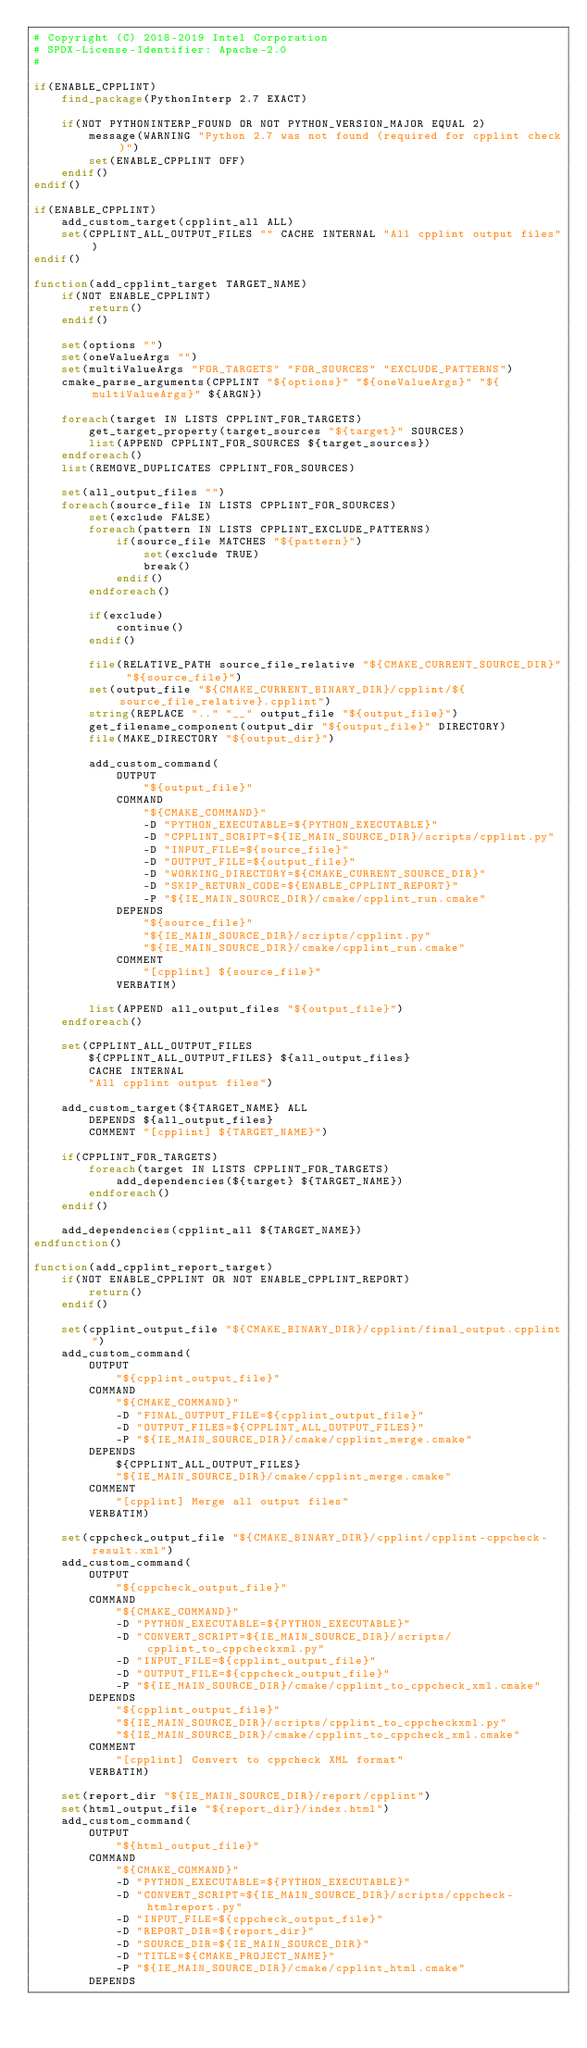<code> <loc_0><loc_0><loc_500><loc_500><_CMake_># Copyright (C) 2018-2019 Intel Corporation
# SPDX-License-Identifier: Apache-2.0
#

if(ENABLE_CPPLINT)
    find_package(PythonInterp 2.7 EXACT)

    if(NOT PYTHONINTERP_FOUND OR NOT PYTHON_VERSION_MAJOR EQUAL 2)
        message(WARNING "Python 2.7 was not found (required for cpplint check)")
        set(ENABLE_CPPLINT OFF)
    endif()
endif()

if(ENABLE_CPPLINT)
    add_custom_target(cpplint_all ALL)
    set(CPPLINT_ALL_OUTPUT_FILES "" CACHE INTERNAL "All cpplint output files")
endif()

function(add_cpplint_target TARGET_NAME)
    if(NOT ENABLE_CPPLINT)
        return()
    endif()

    set(options "")
    set(oneValueArgs "")
    set(multiValueArgs "FOR_TARGETS" "FOR_SOURCES" "EXCLUDE_PATTERNS")
    cmake_parse_arguments(CPPLINT "${options}" "${oneValueArgs}" "${multiValueArgs}" ${ARGN})

    foreach(target IN LISTS CPPLINT_FOR_TARGETS)
        get_target_property(target_sources "${target}" SOURCES)
        list(APPEND CPPLINT_FOR_SOURCES ${target_sources})
    endforeach()
    list(REMOVE_DUPLICATES CPPLINT_FOR_SOURCES)

    set(all_output_files "")
    foreach(source_file IN LISTS CPPLINT_FOR_SOURCES)
        set(exclude FALSE)
        foreach(pattern IN LISTS CPPLINT_EXCLUDE_PATTERNS)
            if(source_file MATCHES "${pattern}")
                set(exclude TRUE)
                break()
            endif()
        endforeach()

        if(exclude)
            continue()
        endif()

        file(RELATIVE_PATH source_file_relative "${CMAKE_CURRENT_SOURCE_DIR}" "${source_file}")
        set(output_file "${CMAKE_CURRENT_BINARY_DIR}/cpplint/${source_file_relative}.cpplint")
        string(REPLACE ".." "__" output_file "${output_file}")
        get_filename_component(output_dir "${output_file}" DIRECTORY)
        file(MAKE_DIRECTORY "${output_dir}")

        add_custom_command(
            OUTPUT
                "${output_file}"
            COMMAND
                "${CMAKE_COMMAND}"
                -D "PYTHON_EXECUTABLE=${PYTHON_EXECUTABLE}"
                -D "CPPLINT_SCRIPT=${IE_MAIN_SOURCE_DIR}/scripts/cpplint.py"
                -D "INPUT_FILE=${source_file}"
                -D "OUTPUT_FILE=${output_file}"
                -D "WORKING_DIRECTORY=${CMAKE_CURRENT_SOURCE_DIR}"
                -D "SKIP_RETURN_CODE=${ENABLE_CPPLINT_REPORT}"
                -P "${IE_MAIN_SOURCE_DIR}/cmake/cpplint_run.cmake"
            DEPENDS
                "${source_file}"
                "${IE_MAIN_SOURCE_DIR}/scripts/cpplint.py"
                "${IE_MAIN_SOURCE_DIR}/cmake/cpplint_run.cmake"
            COMMENT
                "[cpplint] ${source_file}"
            VERBATIM)

        list(APPEND all_output_files "${output_file}")
    endforeach()

    set(CPPLINT_ALL_OUTPUT_FILES
        ${CPPLINT_ALL_OUTPUT_FILES} ${all_output_files}
        CACHE INTERNAL
        "All cpplint output files")

    add_custom_target(${TARGET_NAME} ALL
        DEPENDS ${all_output_files}
        COMMENT "[cpplint] ${TARGET_NAME}")

    if(CPPLINT_FOR_TARGETS)
        foreach(target IN LISTS CPPLINT_FOR_TARGETS)
            add_dependencies(${target} ${TARGET_NAME})
        endforeach()
    endif()

    add_dependencies(cpplint_all ${TARGET_NAME})
endfunction()

function(add_cpplint_report_target)
    if(NOT ENABLE_CPPLINT OR NOT ENABLE_CPPLINT_REPORT)
        return()
    endif()

    set(cpplint_output_file "${CMAKE_BINARY_DIR}/cpplint/final_output.cpplint")
    add_custom_command(
        OUTPUT
            "${cpplint_output_file}"
        COMMAND
            "${CMAKE_COMMAND}"
            -D "FINAL_OUTPUT_FILE=${cpplint_output_file}"
            -D "OUTPUT_FILES=${CPPLINT_ALL_OUTPUT_FILES}"
            -P "${IE_MAIN_SOURCE_DIR}/cmake/cpplint_merge.cmake"
        DEPENDS
            ${CPPLINT_ALL_OUTPUT_FILES}
            "${IE_MAIN_SOURCE_DIR}/cmake/cpplint_merge.cmake"
        COMMENT
            "[cpplint] Merge all output files"
        VERBATIM)

    set(cppcheck_output_file "${CMAKE_BINARY_DIR}/cpplint/cpplint-cppcheck-result.xml")
    add_custom_command(
        OUTPUT
            "${cppcheck_output_file}"
        COMMAND
            "${CMAKE_COMMAND}"
            -D "PYTHON_EXECUTABLE=${PYTHON_EXECUTABLE}"
            -D "CONVERT_SCRIPT=${IE_MAIN_SOURCE_DIR}/scripts/cpplint_to_cppcheckxml.py"
            -D "INPUT_FILE=${cpplint_output_file}"
            -D "OUTPUT_FILE=${cppcheck_output_file}"
            -P "${IE_MAIN_SOURCE_DIR}/cmake/cpplint_to_cppcheck_xml.cmake"
        DEPENDS
            "${cpplint_output_file}"
            "${IE_MAIN_SOURCE_DIR}/scripts/cpplint_to_cppcheckxml.py"
            "${IE_MAIN_SOURCE_DIR}/cmake/cpplint_to_cppcheck_xml.cmake"
        COMMENT
            "[cpplint] Convert to cppcheck XML format"
        VERBATIM)

    set(report_dir "${IE_MAIN_SOURCE_DIR}/report/cpplint")
    set(html_output_file "${report_dir}/index.html")
    add_custom_command(
        OUTPUT
            "${html_output_file}"
        COMMAND
            "${CMAKE_COMMAND}"
            -D "PYTHON_EXECUTABLE=${PYTHON_EXECUTABLE}"
            -D "CONVERT_SCRIPT=${IE_MAIN_SOURCE_DIR}/scripts/cppcheck-htmlreport.py"
            -D "INPUT_FILE=${cppcheck_output_file}"
            -D "REPORT_DIR=${report_dir}"
            -D "SOURCE_DIR=${IE_MAIN_SOURCE_DIR}"
            -D "TITLE=${CMAKE_PROJECT_NAME}"
            -P "${IE_MAIN_SOURCE_DIR}/cmake/cpplint_html.cmake"
        DEPENDS</code> 